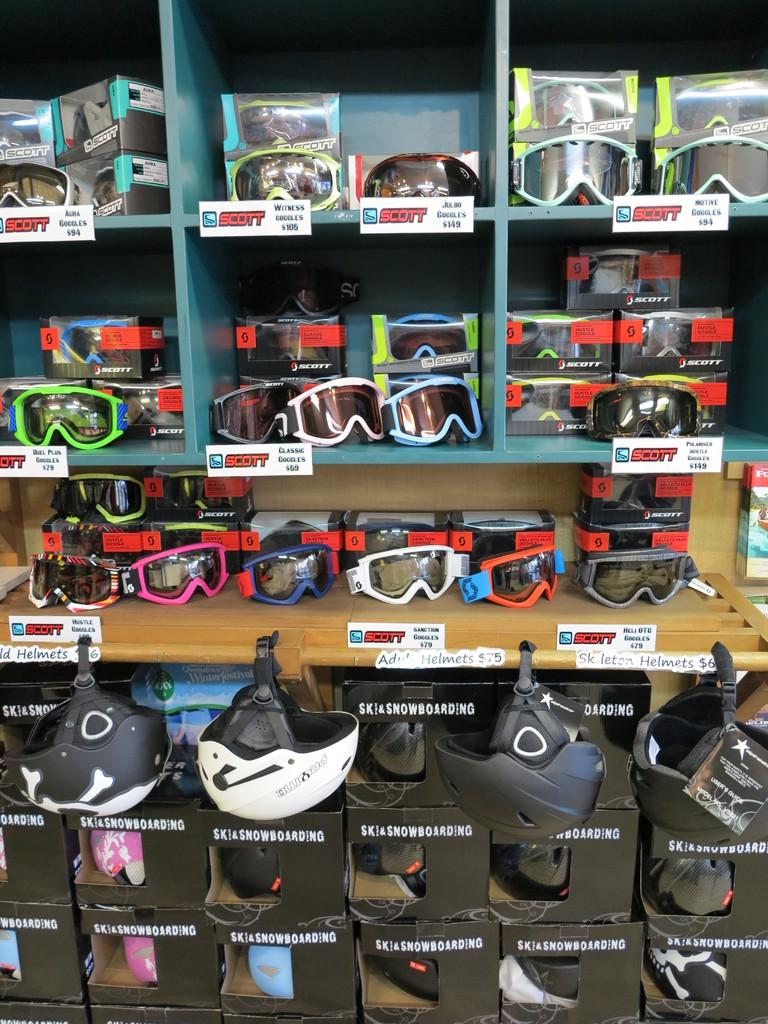What type of furniture is present in the image? There is a wall shelf and tables in the image. What items can be found on the wall shelf? The wall shelf contains goggles. What items can be found on the tables? The tables contain goggles as well. What protective gear is located at the bottom of the image? There are helmets at the bottom of the image. Can you see a deer grazing on the loaf of bread in the image? There is no deer or loaf of bread present in the image. 